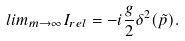Convert formula to latex. <formula><loc_0><loc_0><loc_500><loc_500>l i m _ { m \rightarrow \infty } I _ { r e l } = - i \frac { g } { 2 } \delta ^ { 2 } ( \tilde { p } ) .</formula> 